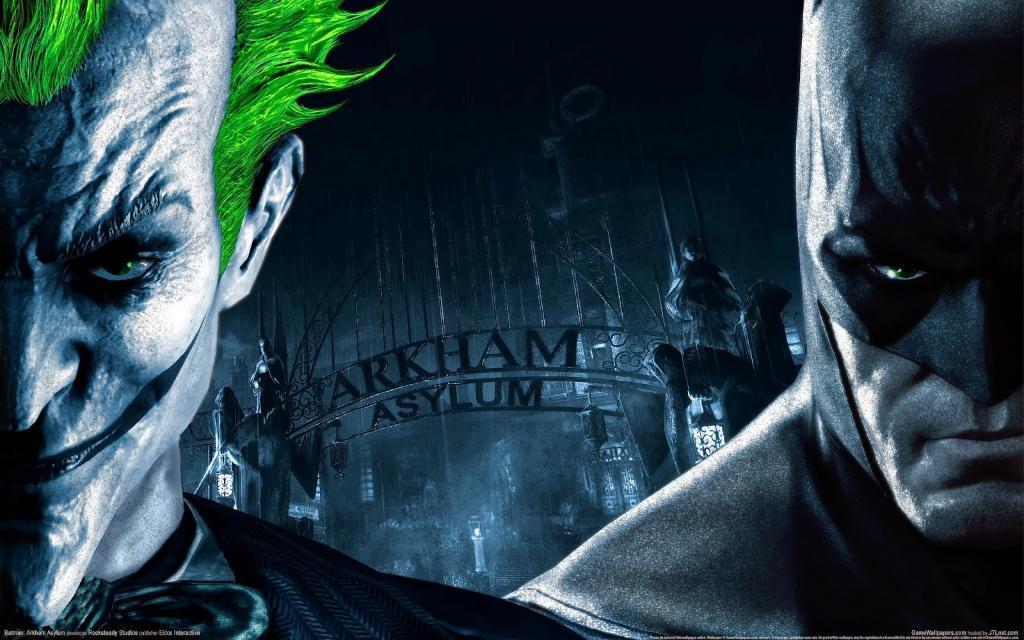Please provide a concise description of this image. This is an edited image. In this image we can see two persons, sculptures, lights and also the arch. We can also see the text at the bottom. 